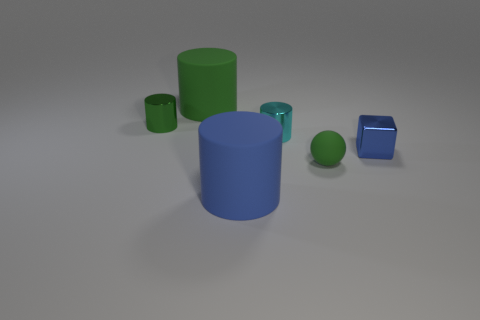Add 4 yellow matte balls. How many objects exist? 10 Subtract all cylinders. How many objects are left? 2 Add 3 purple metal objects. How many purple metal objects exist? 3 Subtract 0 red spheres. How many objects are left? 6 Subtract all purple objects. Subtract all large blue things. How many objects are left? 5 Add 6 cyan things. How many cyan things are left? 7 